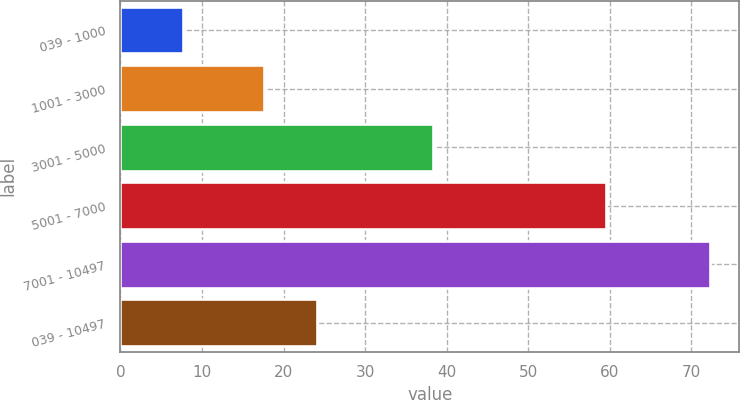<chart> <loc_0><loc_0><loc_500><loc_500><bar_chart><fcel>039 - 1000<fcel>1001 - 3000<fcel>3001 - 5000<fcel>5001 - 7000<fcel>7001 - 10497<fcel>039 - 10497<nl><fcel>7.66<fcel>17.61<fcel>38.3<fcel>59.54<fcel>72.29<fcel>24.07<nl></chart> 